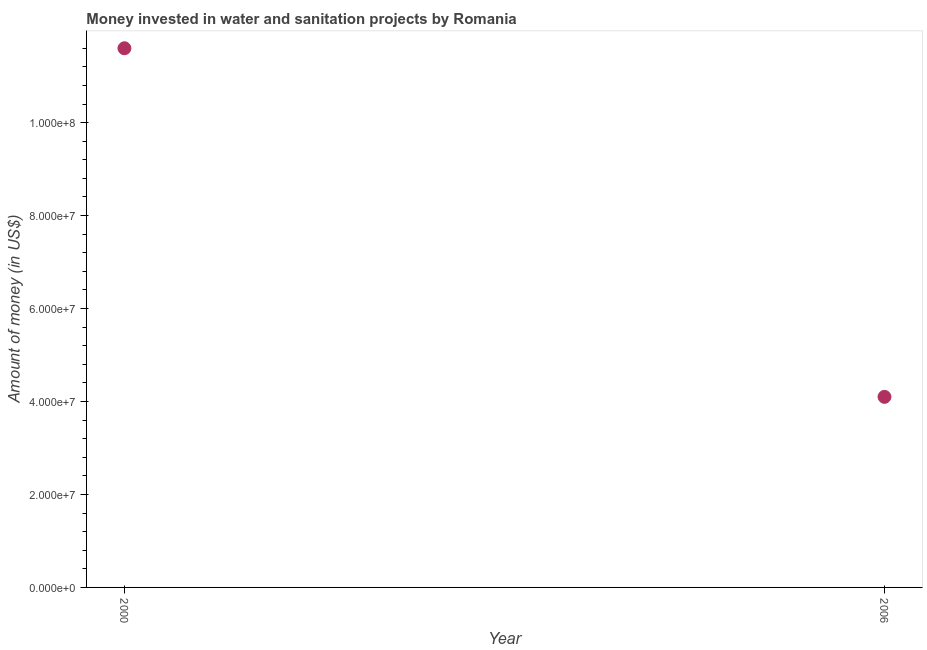What is the investment in 2000?
Your answer should be compact. 1.16e+08. Across all years, what is the maximum investment?
Your answer should be very brief. 1.16e+08. Across all years, what is the minimum investment?
Your answer should be compact. 4.10e+07. In which year was the investment minimum?
Offer a very short reply. 2006. What is the sum of the investment?
Give a very brief answer. 1.57e+08. What is the difference between the investment in 2000 and 2006?
Offer a terse response. 7.50e+07. What is the average investment per year?
Ensure brevity in your answer.  7.85e+07. What is the median investment?
Your answer should be very brief. 7.85e+07. In how many years, is the investment greater than 96000000 US$?
Your response must be concise. 1. What is the ratio of the investment in 2000 to that in 2006?
Give a very brief answer. 2.83. Does the investment monotonically increase over the years?
Give a very brief answer. No. How many years are there in the graph?
Your response must be concise. 2. Does the graph contain any zero values?
Your response must be concise. No. Does the graph contain grids?
Give a very brief answer. No. What is the title of the graph?
Your answer should be very brief. Money invested in water and sanitation projects by Romania. What is the label or title of the X-axis?
Provide a succinct answer. Year. What is the label or title of the Y-axis?
Ensure brevity in your answer.  Amount of money (in US$). What is the Amount of money (in US$) in 2000?
Offer a very short reply. 1.16e+08. What is the Amount of money (in US$) in 2006?
Offer a terse response. 4.10e+07. What is the difference between the Amount of money (in US$) in 2000 and 2006?
Provide a short and direct response. 7.50e+07. What is the ratio of the Amount of money (in US$) in 2000 to that in 2006?
Ensure brevity in your answer.  2.83. 